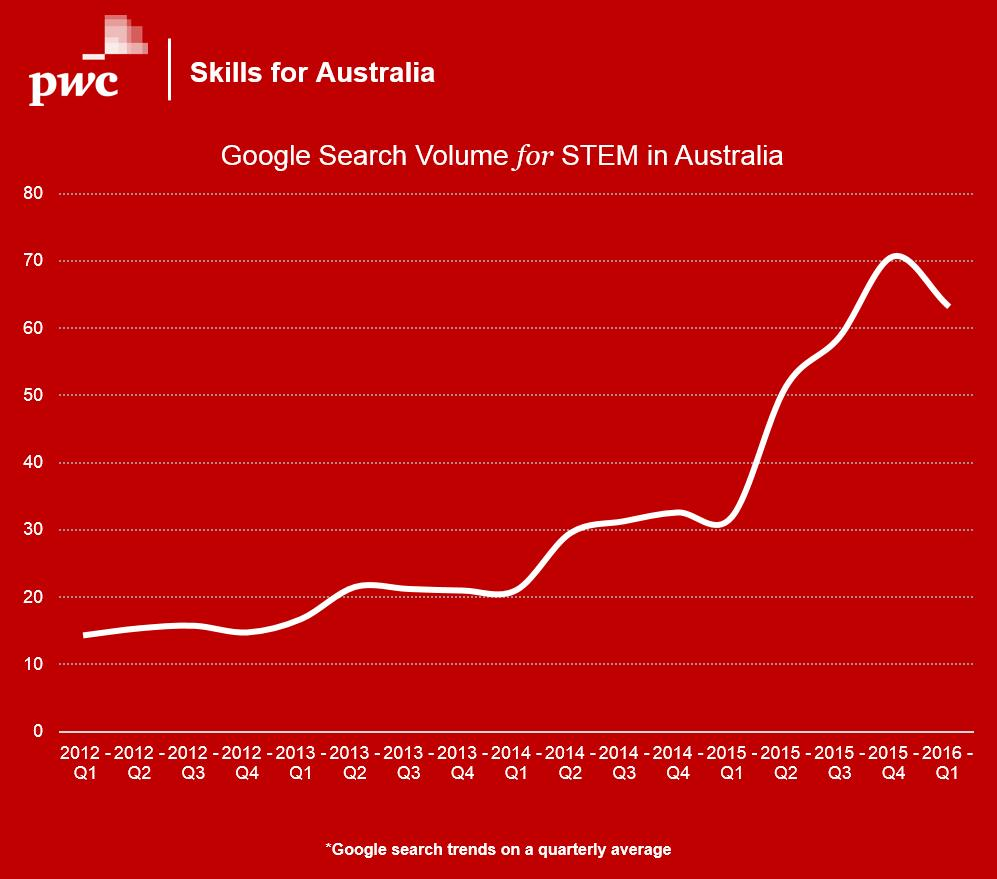Specify some key components in this picture. The volume for 2016 Q1 was lower compared to 2015 Q4. 